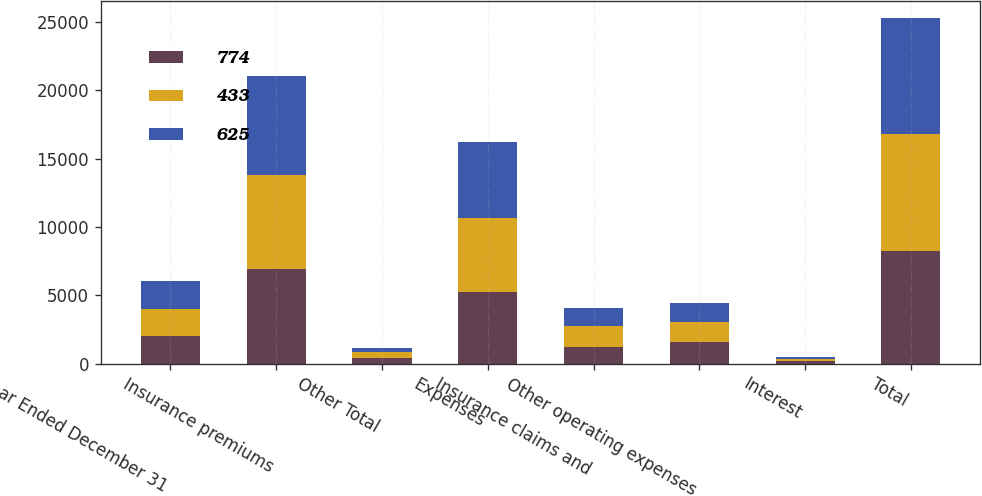Convert chart. <chart><loc_0><loc_0><loc_500><loc_500><stacked_bar_chart><ecel><fcel>Year Ended December 31<fcel>Insurance premiums<fcel>Other Total<fcel>Expenses<fcel>Insurance claims and<fcel>Other operating expenses<fcel>Interest<fcel>Total<nl><fcel>774<fcel>2016<fcel>6924<fcel>410<fcel>5283<fcel>1235<fcel>1558<fcel>167<fcel>8243<nl><fcel>433<fcel>2015<fcel>6921<fcel>411<fcel>5384<fcel>1540<fcel>1469<fcel>155<fcel>8548<nl><fcel>625<fcel>2014<fcel>7212<fcel>359<fcel>5591<fcel>1317<fcel>1386<fcel>183<fcel>8477<nl></chart> 